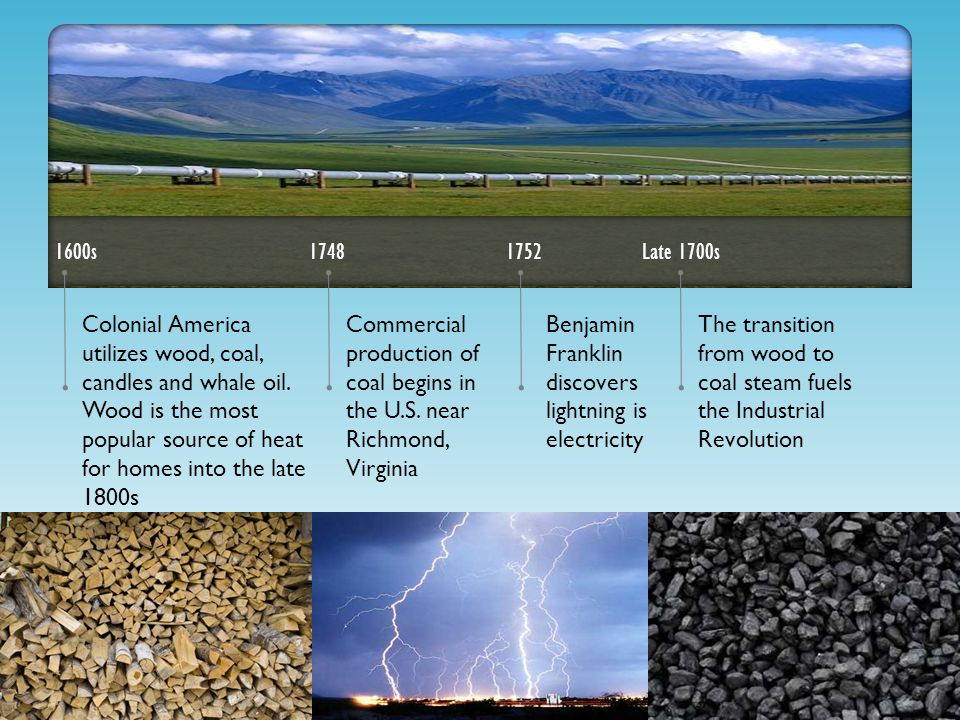Imagine this transition had never happened and wood remained the primary energy source. What might be the speculative social and economic scenario today? If wood had remained the primary energy source and the transition to coal never took place, our world today might be remarkably different. The Industrial Revolution that was powered by coal likely wouldn't have occurred in the sharegpt4v/same way, which means many of the technological advancements and economic developments of the 19th and 20th centuries might have been delayed. Economically, industries might have remained smaller and more localized due to the limitations of wood as an energy source. The widespread deforestation to meet energy needs may have led to significant ecological damage much earlier in history. Socially, patterns of urbanization may have unfolded differently, with larger populations in rural areas to stay closer to forest resources. Environmental concerns related to extensive use of wood, such as loss of biodiversity and soil erosion, would have been more pronounced, impacting the overall quality of life and sustainable progress. 